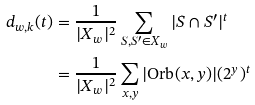Convert formula to latex. <formula><loc_0><loc_0><loc_500><loc_500>d _ { w , k } ( t ) & = \frac { 1 } { | X _ { w } | ^ { 2 } } \sum _ { S , S ^ { \prime } \in X _ { w } } | S \cap S ^ { \prime } | ^ { t } \\ & = \frac { 1 } { | X _ { w } | ^ { 2 } } \sum _ { x , y } | \text {Orb} ( x , y ) | ( 2 ^ { y } ) ^ { t }</formula> 